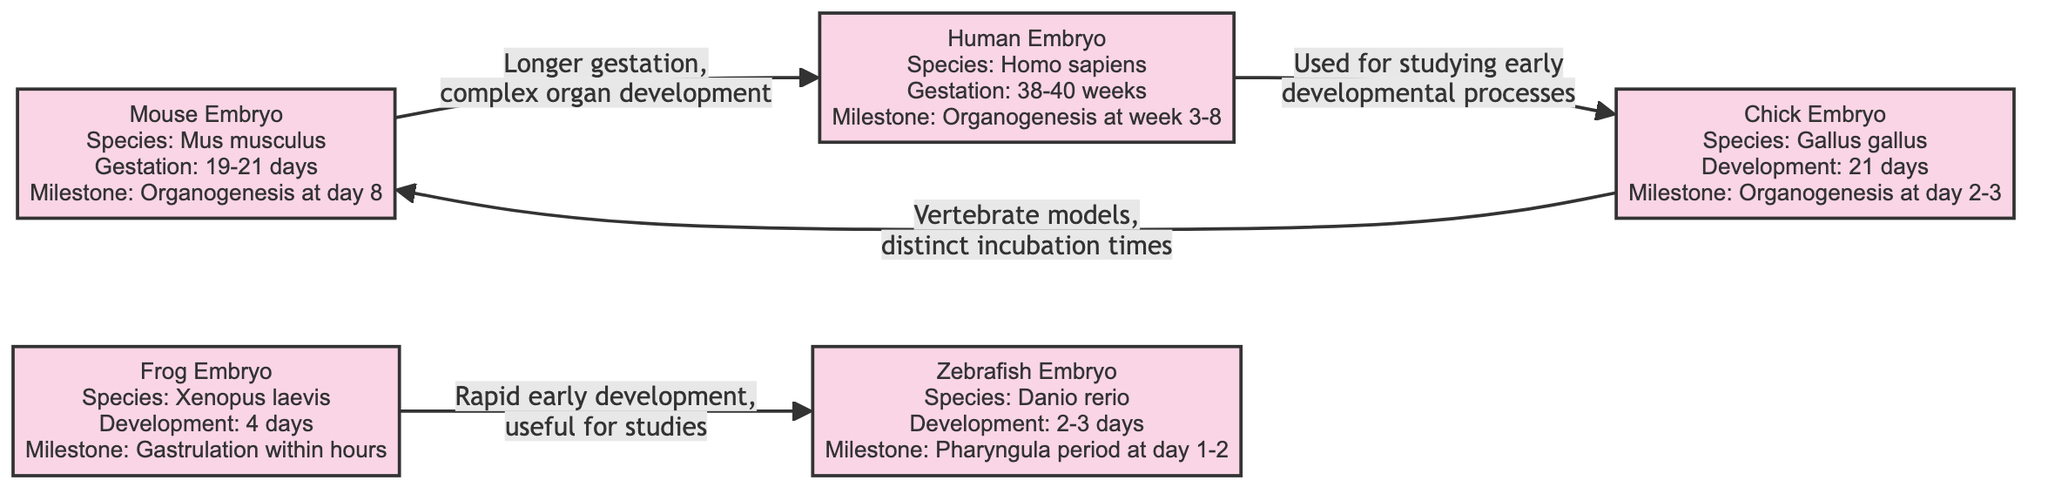What species is the mouse embryo? The diagram explicitly states that the mouse embryo corresponds to the species Mus musculus, which is indicated directly in the text within its node.
Answer: Mus musculus What is the gestation period of the human embryo? In the human embryo node, the gestation period is mentioned as 38-40 weeks, which is clearly labeled there.
Answer: 38-40 weeks Which embryo undergoes organogenesis at day 8? By examining the mouse embryo node, it is stated that organogenesis occurs at day 8 within its development timeline.
Answer: Day 8 What is the milestone for chick embryo development? The chick embryo node presents the milestone for its development as organogenesis occurring at days 2-3, as stated in its specific description.
Answer: Organogenesis at day 2-3 Which two embryos are connected by the relationship of “rapid early development”? This relationship links the frog embryo to the zebrafish embryo, as indicated by the label on the edge connecting these two nodes in the diagram.
Answer: Frog and zebrafish embryos How long does the zebrafish embryo take to develop? The zebrafish embryo node specifies that its development period is 2-3 days, and this information can be found directly in that label.
Answer: 2-3 days What is a notable feature of the human embryo according to the diagram? The diagram states that the human embryo is used for studying early developmental processes, which is highlighted in the label associated with this node.
Answer: Used for studying early developmental processes Which embryo development is described as having a "distinct incubation time"? The chick embryo node characterizes its development by having distinct incubation times, specifically mentioned in the associated edge label in relation to its uniqueness.
Answer: Chick embryo How many embryo nodes are there in the diagram? By counting each distinct node representing an embryo in the diagram, we find there are five total nodes labeled for the mouse, human, frog, chick, and zebrafish embryos.
Answer: 5 